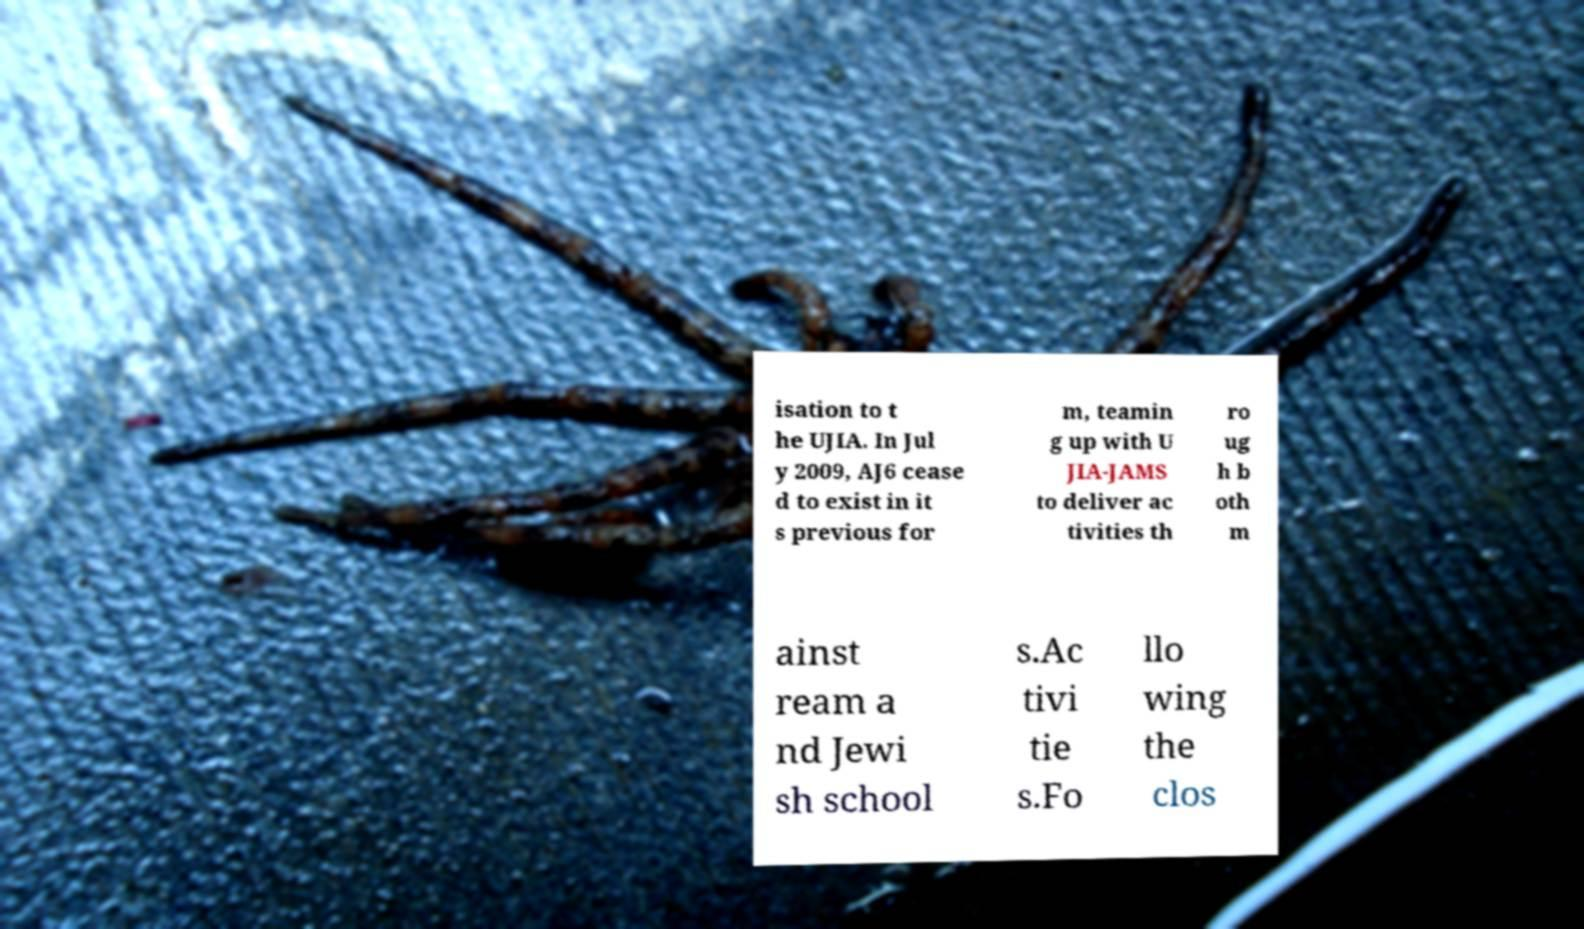Could you extract and type out the text from this image? isation to t he UJIA. In Jul y 2009, AJ6 cease d to exist in it s previous for m, teamin g up with U JIA-JAMS to deliver ac tivities th ro ug h b oth m ainst ream a nd Jewi sh school s.Ac tivi tie s.Fo llo wing the clos 